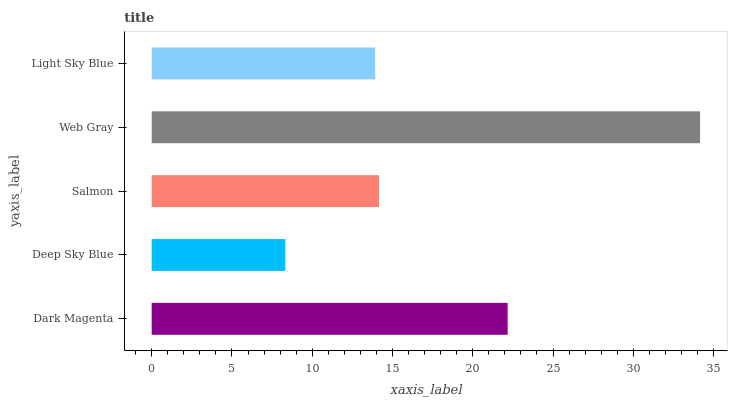Is Deep Sky Blue the minimum?
Answer yes or no. Yes. Is Web Gray the maximum?
Answer yes or no. Yes. Is Salmon the minimum?
Answer yes or no. No. Is Salmon the maximum?
Answer yes or no. No. Is Salmon greater than Deep Sky Blue?
Answer yes or no. Yes. Is Deep Sky Blue less than Salmon?
Answer yes or no. Yes. Is Deep Sky Blue greater than Salmon?
Answer yes or no. No. Is Salmon less than Deep Sky Blue?
Answer yes or no. No. Is Salmon the high median?
Answer yes or no. Yes. Is Salmon the low median?
Answer yes or no. Yes. Is Dark Magenta the high median?
Answer yes or no. No. Is Dark Magenta the low median?
Answer yes or no. No. 